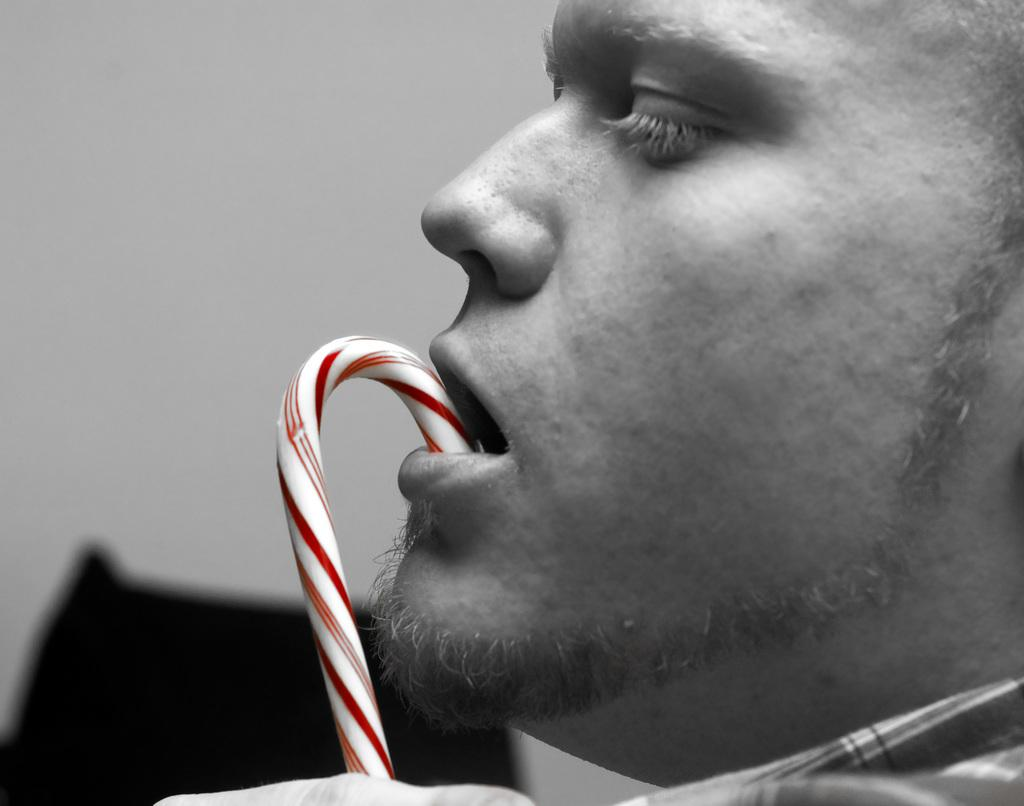What is the main subject in the front of the image? There is a person's face in the front of the image. What else can be seen in the front of the image besides the person's face? There is an object in the front of the image. How would you describe the background of the image? The background of the image is blurry. What type of lunch is being served in the image? There is no lunch present in the image; it features a person's face and an object in the front, with a blurry background. Can you hear the bells ringing in the image? There are no bells or sounds present in the image, as it is a still photograph. 